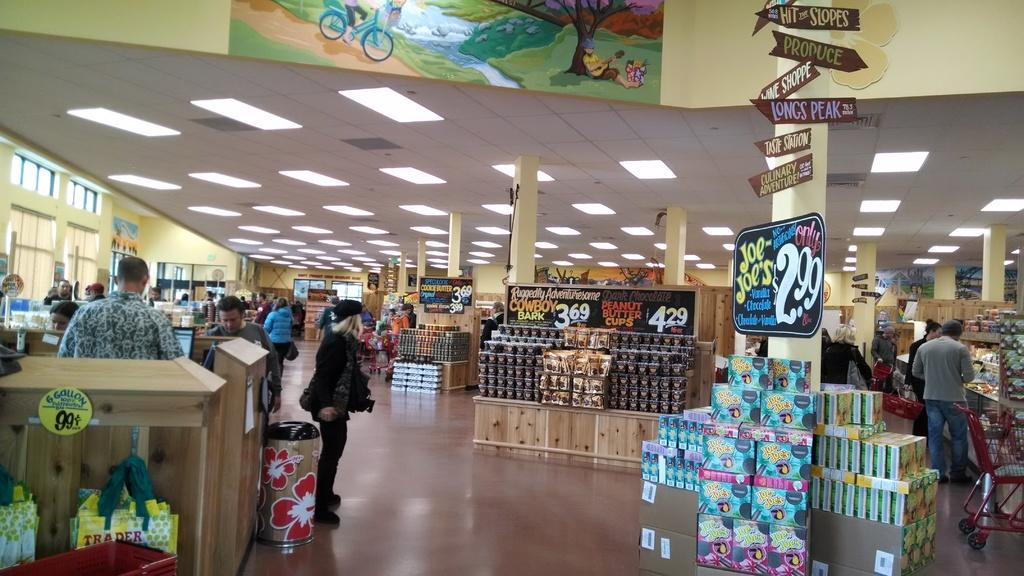<image>
Share a concise interpretation of the image provided. Advertisement for Joe Joe's in a store for 2.99 